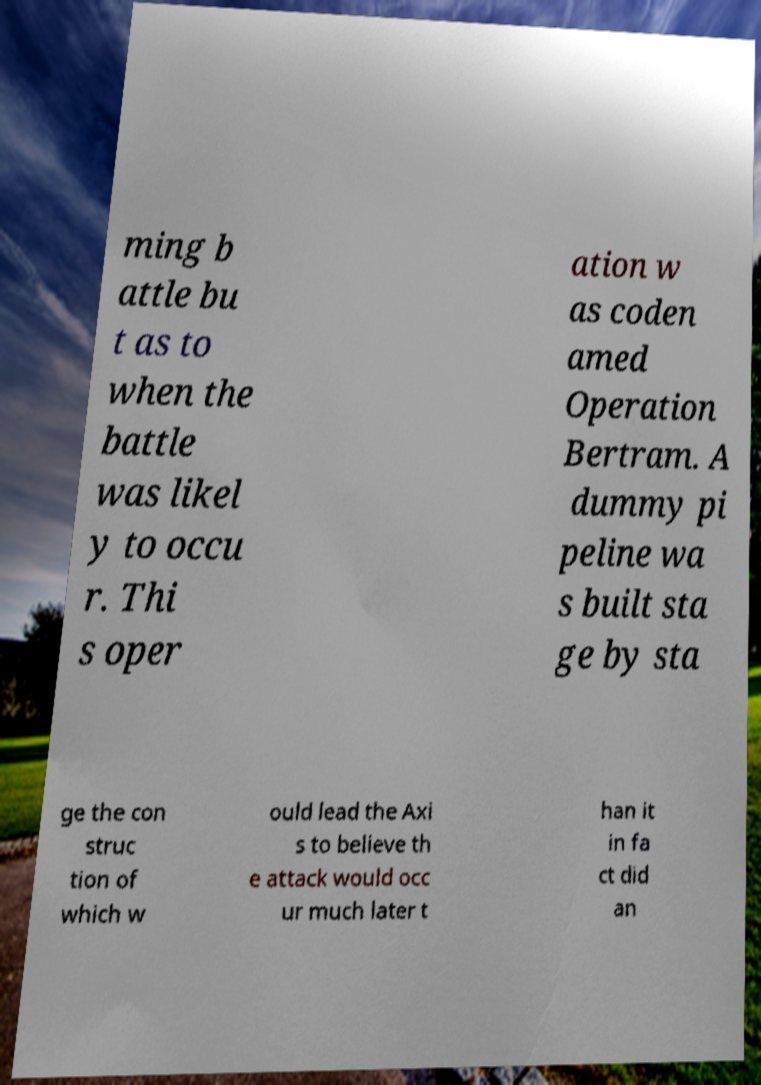For documentation purposes, I need the text within this image transcribed. Could you provide that? ming b attle bu t as to when the battle was likel y to occu r. Thi s oper ation w as coden amed Operation Bertram. A dummy pi peline wa s built sta ge by sta ge the con struc tion of which w ould lead the Axi s to believe th e attack would occ ur much later t han it in fa ct did an 